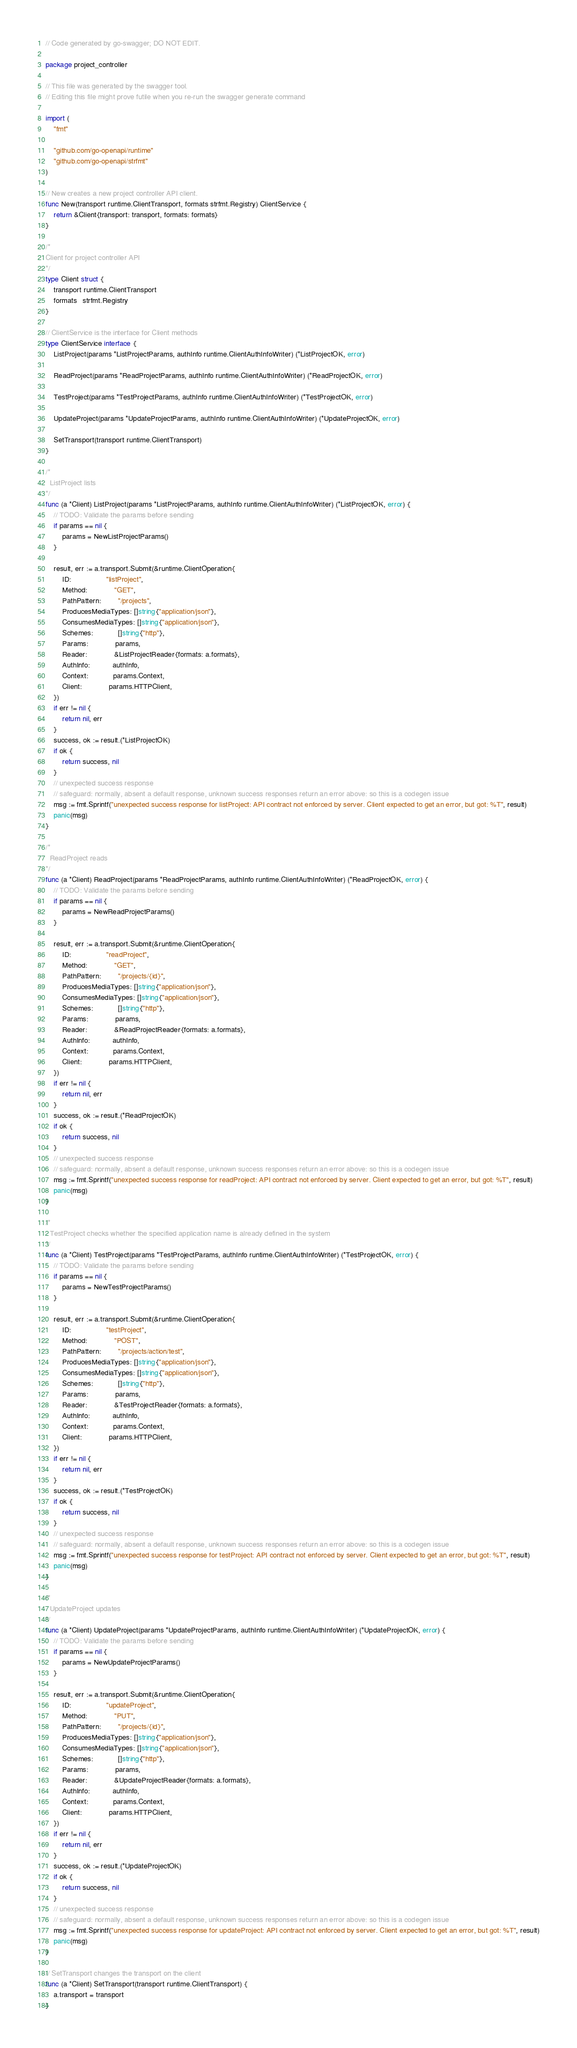<code> <loc_0><loc_0><loc_500><loc_500><_Go_>// Code generated by go-swagger; DO NOT EDIT.

package project_controller

// This file was generated by the swagger tool.
// Editing this file might prove futile when you re-run the swagger generate command

import (
	"fmt"

	"github.com/go-openapi/runtime"
	"github.com/go-openapi/strfmt"
)

// New creates a new project controller API client.
func New(transport runtime.ClientTransport, formats strfmt.Registry) ClientService {
	return &Client{transport: transport, formats: formats}
}

/*
Client for project controller API
*/
type Client struct {
	transport runtime.ClientTransport
	formats   strfmt.Registry
}

// ClientService is the interface for Client methods
type ClientService interface {
	ListProject(params *ListProjectParams, authInfo runtime.ClientAuthInfoWriter) (*ListProjectOK, error)

	ReadProject(params *ReadProjectParams, authInfo runtime.ClientAuthInfoWriter) (*ReadProjectOK, error)

	TestProject(params *TestProjectParams, authInfo runtime.ClientAuthInfoWriter) (*TestProjectOK, error)

	UpdateProject(params *UpdateProjectParams, authInfo runtime.ClientAuthInfoWriter) (*UpdateProjectOK, error)

	SetTransport(transport runtime.ClientTransport)
}

/*
  ListProject lists
*/
func (a *Client) ListProject(params *ListProjectParams, authInfo runtime.ClientAuthInfoWriter) (*ListProjectOK, error) {
	// TODO: Validate the params before sending
	if params == nil {
		params = NewListProjectParams()
	}

	result, err := a.transport.Submit(&runtime.ClientOperation{
		ID:                 "listProject",
		Method:             "GET",
		PathPattern:        "/projects",
		ProducesMediaTypes: []string{"application/json"},
		ConsumesMediaTypes: []string{"application/json"},
		Schemes:            []string{"http"},
		Params:             params,
		Reader:             &ListProjectReader{formats: a.formats},
		AuthInfo:           authInfo,
		Context:            params.Context,
		Client:             params.HTTPClient,
	})
	if err != nil {
		return nil, err
	}
	success, ok := result.(*ListProjectOK)
	if ok {
		return success, nil
	}
	// unexpected success response
	// safeguard: normally, absent a default response, unknown success responses return an error above: so this is a codegen issue
	msg := fmt.Sprintf("unexpected success response for listProject: API contract not enforced by server. Client expected to get an error, but got: %T", result)
	panic(msg)
}

/*
  ReadProject reads
*/
func (a *Client) ReadProject(params *ReadProjectParams, authInfo runtime.ClientAuthInfoWriter) (*ReadProjectOK, error) {
	// TODO: Validate the params before sending
	if params == nil {
		params = NewReadProjectParams()
	}

	result, err := a.transport.Submit(&runtime.ClientOperation{
		ID:                 "readProject",
		Method:             "GET",
		PathPattern:        "/projects/{id}",
		ProducesMediaTypes: []string{"application/json"},
		ConsumesMediaTypes: []string{"application/json"},
		Schemes:            []string{"http"},
		Params:             params,
		Reader:             &ReadProjectReader{formats: a.formats},
		AuthInfo:           authInfo,
		Context:            params.Context,
		Client:             params.HTTPClient,
	})
	if err != nil {
		return nil, err
	}
	success, ok := result.(*ReadProjectOK)
	if ok {
		return success, nil
	}
	// unexpected success response
	// safeguard: normally, absent a default response, unknown success responses return an error above: so this is a codegen issue
	msg := fmt.Sprintf("unexpected success response for readProject: API contract not enforced by server. Client expected to get an error, but got: %T", result)
	panic(msg)
}

/*
  TestProject checks whether the specified application name is already defined in the system
*/
func (a *Client) TestProject(params *TestProjectParams, authInfo runtime.ClientAuthInfoWriter) (*TestProjectOK, error) {
	// TODO: Validate the params before sending
	if params == nil {
		params = NewTestProjectParams()
	}

	result, err := a.transport.Submit(&runtime.ClientOperation{
		ID:                 "testProject",
		Method:             "POST",
		PathPattern:        "/projects/action/test",
		ProducesMediaTypes: []string{"application/json"},
		ConsumesMediaTypes: []string{"application/json"},
		Schemes:            []string{"http"},
		Params:             params,
		Reader:             &TestProjectReader{formats: a.formats},
		AuthInfo:           authInfo,
		Context:            params.Context,
		Client:             params.HTTPClient,
	})
	if err != nil {
		return nil, err
	}
	success, ok := result.(*TestProjectOK)
	if ok {
		return success, nil
	}
	// unexpected success response
	// safeguard: normally, absent a default response, unknown success responses return an error above: so this is a codegen issue
	msg := fmt.Sprintf("unexpected success response for testProject: API contract not enforced by server. Client expected to get an error, but got: %T", result)
	panic(msg)
}

/*
  UpdateProject updates
*/
func (a *Client) UpdateProject(params *UpdateProjectParams, authInfo runtime.ClientAuthInfoWriter) (*UpdateProjectOK, error) {
	// TODO: Validate the params before sending
	if params == nil {
		params = NewUpdateProjectParams()
	}

	result, err := a.transport.Submit(&runtime.ClientOperation{
		ID:                 "updateProject",
		Method:             "PUT",
		PathPattern:        "/projects/{id}",
		ProducesMediaTypes: []string{"application/json"},
		ConsumesMediaTypes: []string{"application/json"},
		Schemes:            []string{"http"},
		Params:             params,
		Reader:             &UpdateProjectReader{formats: a.formats},
		AuthInfo:           authInfo,
		Context:            params.Context,
		Client:             params.HTTPClient,
	})
	if err != nil {
		return nil, err
	}
	success, ok := result.(*UpdateProjectOK)
	if ok {
		return success, nil
	}
	// unexpected success response
	// safeguard: normally, absent a default response, unknown success responses return an error above: so this is a codegen issue
	msg := fmt.Sprintf("unexpected success response for updateProject: API contract not enforced by server. Client expected to get an error, but got: %T", result)
	panic(msg)
}

// SetTransport changes the transport on the client
func (a *Client) SetTransport(transport runtime.ClientTransport) {
	a.transport = transport
}
</code> 